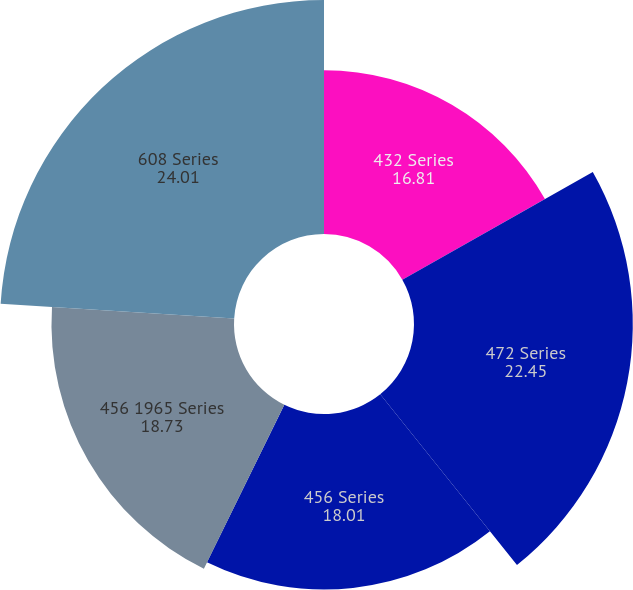Convert chart to OTSL. <chart><loc_0><loc_0><loc_500><loc_500><pie_chart><fcel>432 Series<fcel>472 Series<fcel>456 Series<fcel>456 1965 Series<fcel>608 Series<nl><fcel>16.81%<fcel>22.45%<fcel>18.01%<fcel>18.73%<fcel>24.01%<nl></chart> 